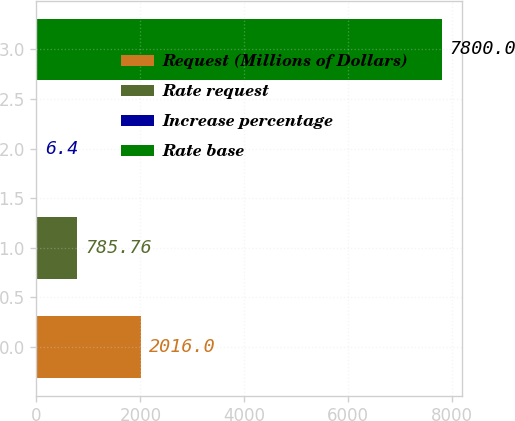Convert chart. <chart><loc_0><loc_0><loc_500><loc_500><bar_chart><fcel>Request (Millions of Dollars)<fcel>Rate request<fcel>Increase percentage<fcel>Rate base<nl><fcel>2016<fcel>785.76<fcel>6.4<fcel>7800<nl></chart> 